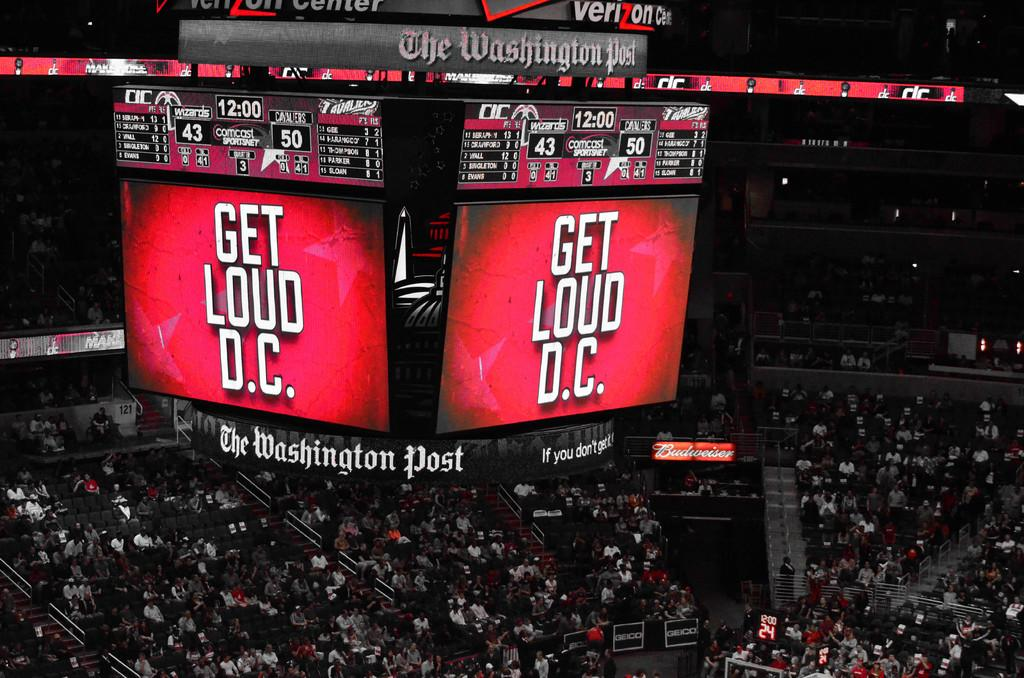<image>
Relay a brief, clear account of the picture shown. The large screen at a sporting event states Get Loud D.C. 